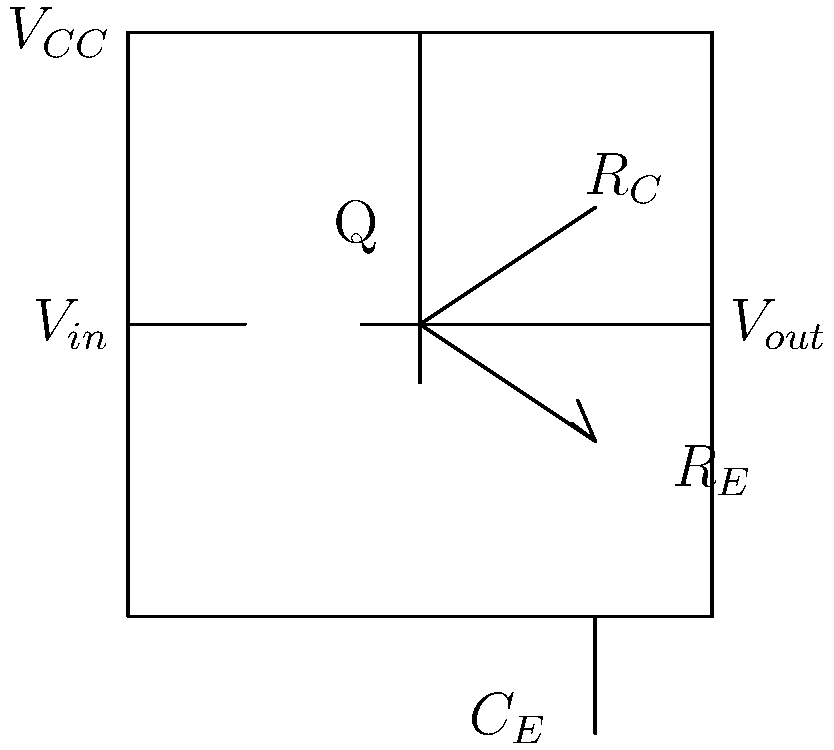In the common-emitter amplifier circuit shown above, if the transistor has a current gain (β) of 100, $R_C = 2$ kΩ, $R_E = 200$ Ω, and the input signal frequency is 1 kHz, calculate the voltage gain and phase shift of the output signal relative to the input. Assume the capacitor $C_E$ fully bypasses $R_E$ at this frequency. Let's approach this step-by-step:

1) First, we need to calculate the small-signal parameters:
   
   Transconductance, $g_m = \frac{I_C}{V_T}$, where $V_T \approx 26$ mV at room temperature.
   
   We don't know $I_C$, but we can estimate it: $I_C \approx \frac{V_{CC}}{R_C + R_E} \approx \frac{5V}{2.2k\Omega} \approx 2.27$ mA

   So, $g_m \approx \frac{2.27 \text{ mA}}{26 \text{ mV}} \approx 87.3$ mS

2) The voltage gain of a common-emitter amplifier is given by:
   
   $A_v = -g_m R_C$ (negative sign indicates 180° phase shift)

3) Substituting the values:
   
   $A_v = -(87.3 \text{ mS})(2 \text{ k}\Omega) = -174.6$

4) The magnitude of the voltage gain is 174.6.

5) The phase shift is 180° due to the negative sign of the gain.

6) Note: We assumed $C_E$ fully bypasses $R_E$. If it didn't, we would need to consider the effect of $R_E$ on the gain and phase shift.
Answer: Voltage gain: 174.6, Phase shift: 180° 